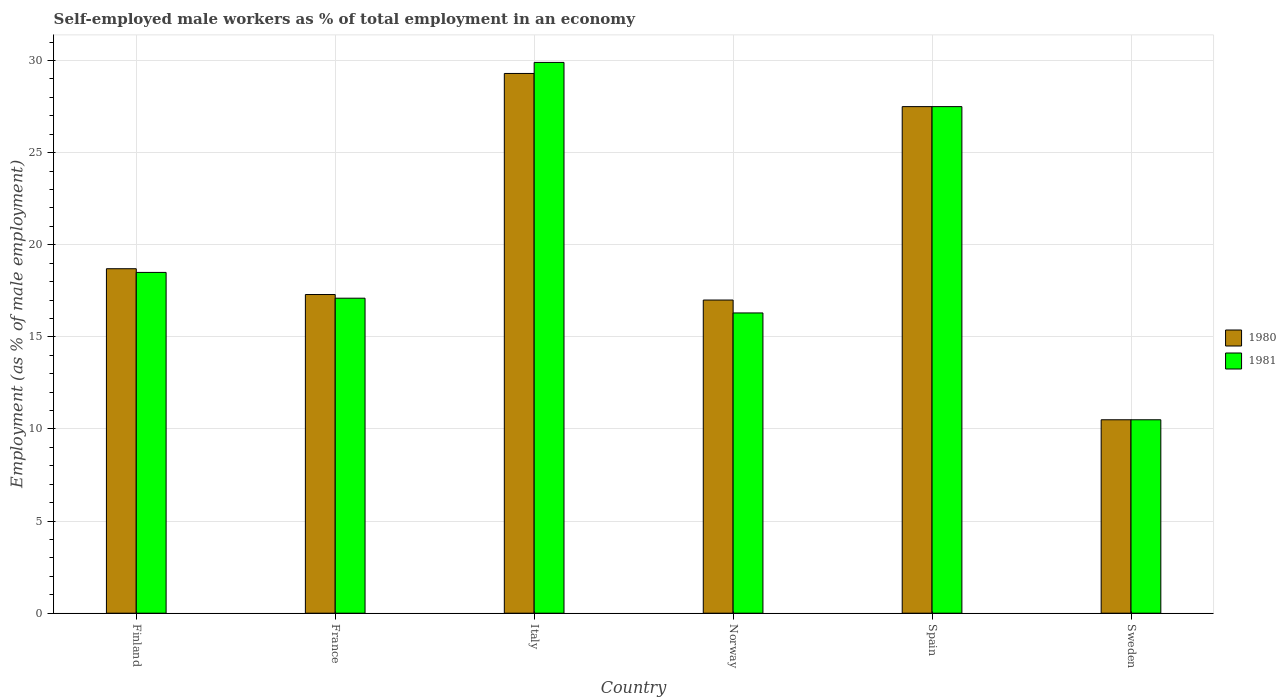How many different coloured bars are there?
Your response must be concise. 2. Are the number of bars on each tick of the X-axis equal?
Provide a short and direct response. Yes. What is the label of the 5th group of bars from the left?
Offer a terse response. Spain. In how many cases, is the number of bars for a given country not equal to the number of legend labels?
Offer a terse response. 0. Across all countries, what is the maximum percentage of self-employed male workers in 1981?
Keep it short and to the point. 29.9. In which country was the percentage of self-employed male workers in 1981 maximum?
Provide a short and direct response. Italy. In which country was the percentage of self-employed male workers in 1980 minimum?
Your answer should be very brief. Sweden. What is the total percentage of self-employed male workers in 1980 in the graph?
Your response must be concise. 120.3. What is the difference between the percentage of self-employed male workers in 1980 in France and that in Spain?
Your response must be concise. -10.2. What is the difference between the percentage of self-employed male workers in 1981 in Norway and the percentage of self-employed male workers in 1980 in Spain?
Ensure brevity in your answer.  -11.2. What is the average percentage of self-employed male workers in 1980 per country?
Provide a succinct answer. 20.05. What is the difference between the percentage of self-employed male workers of/in 1981 and percentage of self-employed male workers of/in 1980 in France?
Your answer should be compact. -0.2. What is the ratio of the percentage of self-employed male workers in 1980 in France to that in Sweden?
Your response must be concise. 1.65. What is the difference between the highest and the second highest percentage of self-employed male workers in 1980?
Provide a short and direct response. -8.8. What is the difference between the highest and the lowest percentage of self-employed male workers in 1981?
Offer a terse response. 19.4. Is the sum of the percentage of self-employed male workers in 1981 in Italy and Norway greater than the maximum percentage of self-employed male workers in 1980 across all countries?
Ensure brevity in your answer.  Yes. Are all the bars in the graph horizontal?
Your response must be concise. No. How many countries are there in the graph?
Provide a short and direct response. 6. How are the legend labels stacked?
Offer a very short reply. Vertical. What is the title of the graph?
Provide a succinct answer. Self-employed male workers as % of total employment in an economy. What is the label or title of the Y-axis?
Keep it short and to the point. Employment (as % of male employment). What is the Employment (as % of male employment) of 1980 in Finland?
Your response must be concise. 18.7. What is the Employment (as % of male employment) of 1981 in Finland?
Provide a short and direct response. 18.5. What is the Employment (as % of male employment) of 1980 in France?
Keep it short and to the point. 17.3. What is the Employment (as % of male employment) in 1981 in France?
Your answer should be compact. 17.1. What is the Employment (as % of male employment) of 1980 in Italy?
Offer a very short reply. 29.3. What is the Employment (as % of male employment) of 1981 in Italy?
Offer a terse response. 29.9. What is the Employment (as % of male employment) of 1981 in Norway?
Keep it short and to the point. 16.3. What is the Employment (as % of male employment) in 1981 in Spain?
Ensure brevity in your answer.  27.5. What is the Employment (as % of male employment) of 1980 in Sweden?
Offer a terse response. 10.5. Across all countries, what is the maximum Employment (as % of male employment) in 1980?
Make the answer very short. 29.3. Across all countries, what is the maximum Employment (as % of male employment) in 1981?
Provide a succinct answer. 29.9. What is the total Employment (as % of male employment) of 1980 in the graph?
Provide a succinct answer. 120.3. What is the total Employment (as % of male employment) in 1981 in the graph?
Your answer should be very brief. 119.8. What is the difference between the Employment (as % of male employment) in 1980 in Finland and that in France?
Ensure brevity in your answer.  1.4. What is the difference between the Employment (as % of male employment) in 1980 in Finland and that in Italy?
Your response must be concise. -10.6. What is the difference between the Employment (as % of male employment) in 1981 in Finland and that in Italy?
Provide a succinct answer. -11.4. What is the difference between the Employment (as % of male employment) of 1981 in Finland and that in Spain?
Offer a terse response. -9. What is the difference between the Employment (as % of male employment) of 1980 in Finland and that in Sweden?
Make the answer very short. 8.2. What is the difference between the Employment (as % of male employment) in 1981 in France and that in Italy?
Offer a terse response. -12.8. What is the difference between the Employment (as % of male employment) in 1980 in France and that in Spain?
Offer a very short reply. -10.2. What is the difference between the Employment (as % of male employment) in 1981 in France and that in Spain?
Your answer should be compact. -10.4. What is the difference between the Employment (as % of male employment) in 1980 in France and that in Sweden?
Give a very brief answer. 6.8. What is the difference between the Employment (as % of male employment) of 1980 in Italy and that in Norway?
Provide a short and direct response. 12.3. What is the difference between the Employment (as % of male employment) of 1981 in Norway and that in Spain?
Give a very brief answer. -11.2. What is the difference between the Employment (as % of male employment) in 1981 in Spain and that in Sweden?
Make the answer very short. 17. What is the difference between the Employment (as % of male employment) in 1980 in Finland and the Employment (as % of male employment) in 1981 in Norway?
Give a very brief answer. 2.4. What is the difference between the Employment (as % of male employment) in 1980 in Finland and the Employment (as % of male employment) in 1981 in Sweden?
Your response must be concise. 8.2. What is the difference between the Employment (as % of male employment) of 1980 in France and the Employment (as % of male employment) of 1981 in Spain?
Your response must be concise. -10.2. What is the difference between the Employment (as % of male employment) of 1980 in Italy and the Employment (as % of male employment) of 1981 in Spain?
Offer a very short reply. 1.8. What is the difference between the Employment (as % of male employment) of 1980 in Norway and the Employment (as % of male employment) of 1981 in Spain?
Your answer should be very brief. -10.5. What is the difference between the Employment (as % of male employment) of 1980 in Norway and the Employment (as % of male employment) of 1981 in Sweden?
Offer a very short reply. 6.5. What is the difference between the Employment (as % of male employment) of 1980 in Spain and the Employment (as % of male employment) of 1981 in Sweden?
Give a very brief answer. 17. What is the average Employment (as % of male employment) of 1980 per country?
Keep it short and to the point. 20.05. What is the average Employment (as % of male employment) of 1981 per country?
Offer a terse response. 19.97. What is the difference between the Employment (as % of male employment) in 1980 and Employment (as % of male employment) in 1981 in Finland?
Ensure brevity in your answer.  0.2. What is the difference between the Employment (as % of male employment) of 1980 and Employment (as % of male employment) of 1981 in Spain?
Offer a terse response. 0. What is the difference between the Employment (as % of male employment) in 1980 and Employment (as % of male employment) in 1981 in Sweden?
Provide a short and direct response. 0. What is the ratio of the Employment (as % of male employment) in 1980 in Finland to that in France?
Your answer should be compact. 1.08. What is the ratio of the Employment (as % of male employment) in 1981 in Finland to that in France?
Your answer should be very brief. 1.08. What is the ratio of the Employment (as % of male employment) of 1980 in Finland to that in Italy?
Provide a short and direct response. 0.64. What is the ratio of the Employment (as % of male employment) in 1981 in Finland to that in Italy?
Provide a short and direct response. 0.62. What is the ratio of the Employment (as % of male employment) of 1980 in Finland to that in Norway?
Ensure brevity in your answer.  1.1. What is the ratio of the Employment (as % of male employment) in 1981 in Finland to that in Norway?
Provide a succinct answer. 1.14. What is the ratio of the Employment (as % of male employment) of 1980 in Finland to that in Spain?
Provide a succinct answer. 0.68. What is the ratio of the Employment (as % of male employment) of 1981 in Finland to that in Spain?
Your response must be concise. 0.67. What is the ratio of the Employment (as % of male employment) in 1980 in Finland to that in Sweden?
Your answer should be compact. 1.78. What is the ratio of the Employment (as % of male employment) in 1981 in Finland to that in Sweden?
Offer a very short reply. 1.76. What is the ratio of the Employment (as % of male employment) of 1980 in France to that in Italy?
Your response must be concise. 0.59. What is the ratio of the Employment (as % of male employment) of 1981 in France to that in Italy?
Offer a very short reply. 0.57. What is the ratio of the Employment (as % of male employment) of 1980 in France to that in Norway?
Ensure brevity in your answer.  1.02. What is the ratio of the Employment (as % of male employment) in 1981 in France to that in Norway?
Your answer should be very brief. 1.05. What is the ratio of the Employment (as % of male employment) in 1980 in France to that in Spain?
Ensure brevity in your answer.  0.63. What is the ratio of the Employment (as % of male employment) of 1981 in France to that in Spain?
Make the answer very short. 0.62. What is the ratio of the Employment (as % of male employment) of 1980 in France to that in Sweden?
Offer a terse response. 1.65. What is the ratio of the Employment (as % of male employment) in 1981 in France to that in Sweden?
Offer a terse response. 1.63. What is the ratio of the Employment (as % of male employment) of 1980 in Italy to that in Norway?
Your answer should be very brief. 1.72. What is the ratio of the Employment (as % of male employment) of 1981 in Italy to that in Norway?
Offer a terse response. 1.83. What is the ratio of the Employment (as % of male employment) in 1980 in Italy to that in Spain?
Your response must be concise. 1.07. What is the ratio of the Employment (as % of male employment) in 1981 in Italy to that in Spain?
Give a very brief answer. 1.09. What is the ratio of the Employment (as % of male employment) in 1980 in Italy to that in Sweden?
Provide a short and direct response. 2.79. What is the ratio of the Employment (as % of male employment) of 1981 in Italy to that in Sweden?
Make the answer very short. 2.85. What is the ratio of the Employment (as % of male employment) in 1980 in Norway to that in Spain?
Give a very brief answer. 0.62. What is the ratio of the Employment (as % of male employment) of 1981 in Norway to that in Spain?
Offer a very short reply. 0.59. What is the ratio of the Employment (as % of male employment) of 1980 in Norway to that in Sweden?
Your response must be concise. 1.62. What is the ratio of the Employment (as % of male employment) of 1981 in Norway to that in Sweden?
Offer a very short reply. 1.55. What is the ratio of the Employment (as % of male employment) of 1980 in Spain to that in Sweden?
Your response must be concise. 2.62. What is the ratio of the Employment (as % of male employment) in 1981 in Spain to that in Sweden?
Offer a very short reply. 2.62. What is the difference between the highest and the lowest Employment (as % of male employment) of 1981?
Give a very brief answer. 19.4. 